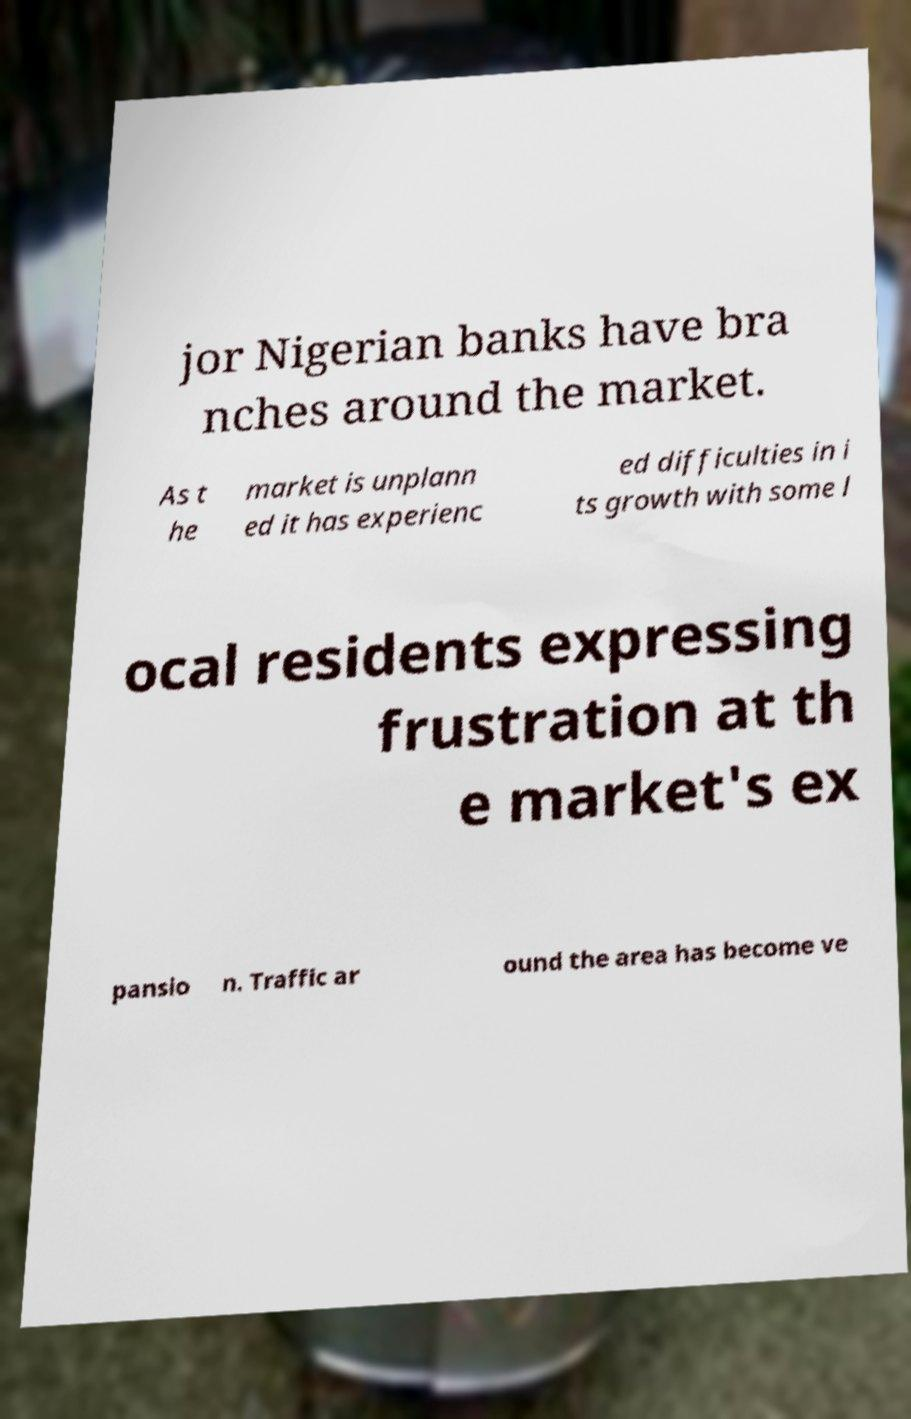Can you read and provide the text displayed in the image?This photo seems to have some interesting text. Can you extract and type it out for me? jor Nigerian banks have bra nches around the market. As t he market is unplann ed it has experienc ed difficulties in i ts growth with some l ocal residents expressing frustration at th e market's ex pansio n. Traffic ar ound the area has become ve 